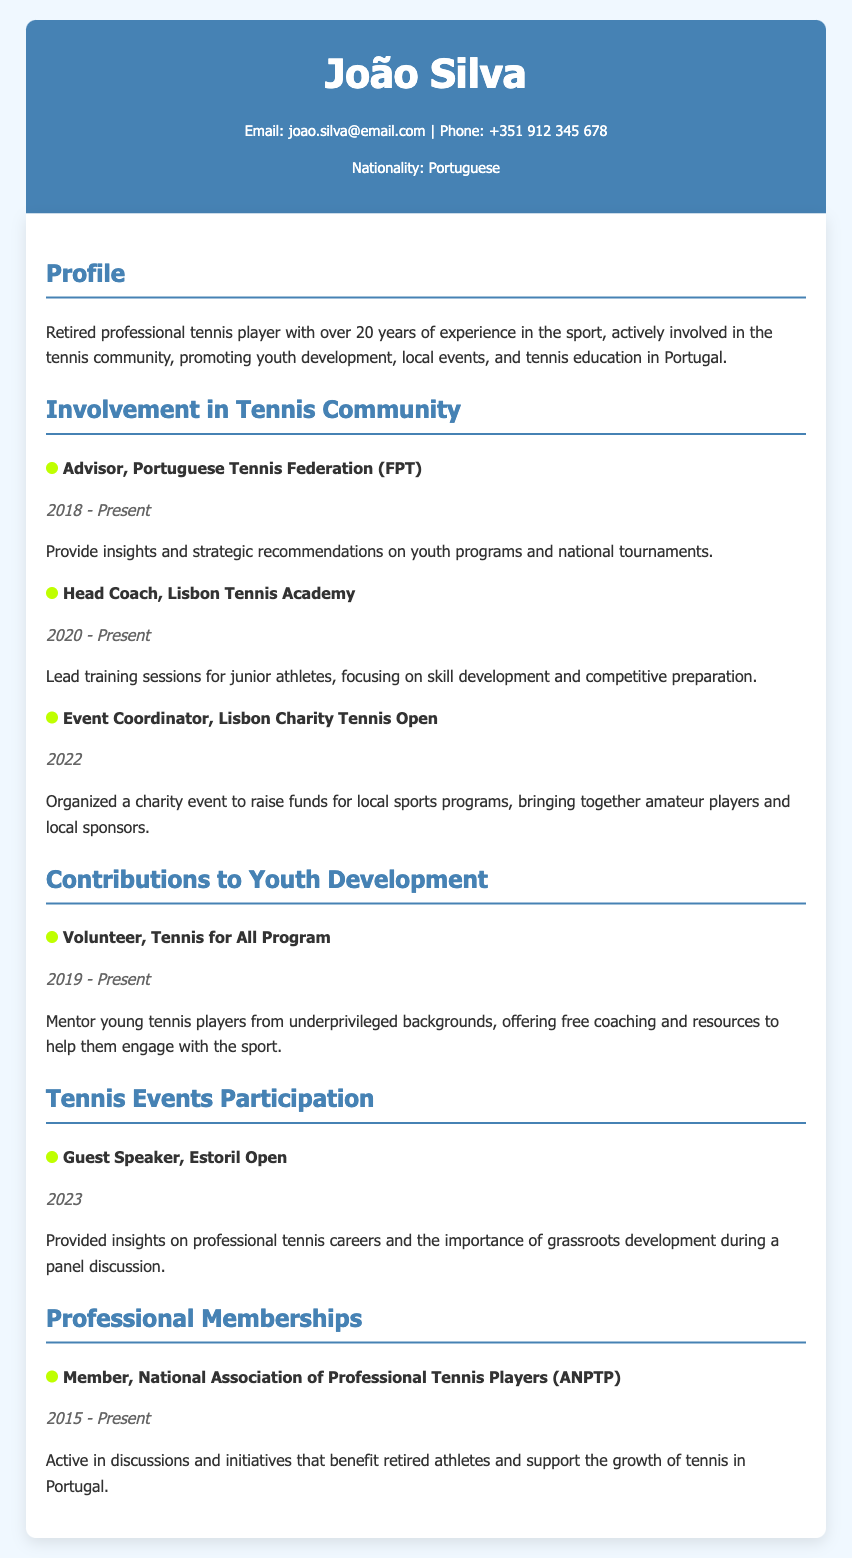What is João Silva's role at the Portuguese Tennis Federation? The role at the Portuguese Tennis Federation is explicitly mentioned in the document as "Advisor."
Answer: Advisor When did João Silva start coaching at the Lisbon Tennis Academy? The starting year for his coaching role at the Lisbon Tennis Academy is provided in the document as 2020.
Answer: 2020 What event did João Silva coordinate in 2022? The document specifies the event he coordinated as the "Lisbon Charity Tennis Open."
Answer: Lisbon Charity Tennis Open How long has João Silva been a member of the National Association of Professional Tennis Players? The document indicates he has been a member since 2015 and has therefore been involved for 8 years.
Answer: 8 years What type of program is "Tennis for All"? The document states that "Tennis for All" is described as a mentoring program for young tennis players from underprivileged backgrounds.
Answer: Mentoring program What position did João Silva hold at the Estoril Open in 2023? The document outlines that he served as a "Guest Speaker" at the Estoril Open.
Answer: Guest Speaker What is the main focus of João Silva's training sessions at the Lisbon Tennis Academy? The document mentions that the focus is on "skill development and competitive preparation."
Answer: Skill development and competitive preparation In what year did João Silva begin his volunteer efforts with the Tennis for All Program? The document indicates he started volunteering in 2019.
Answer: 2019 